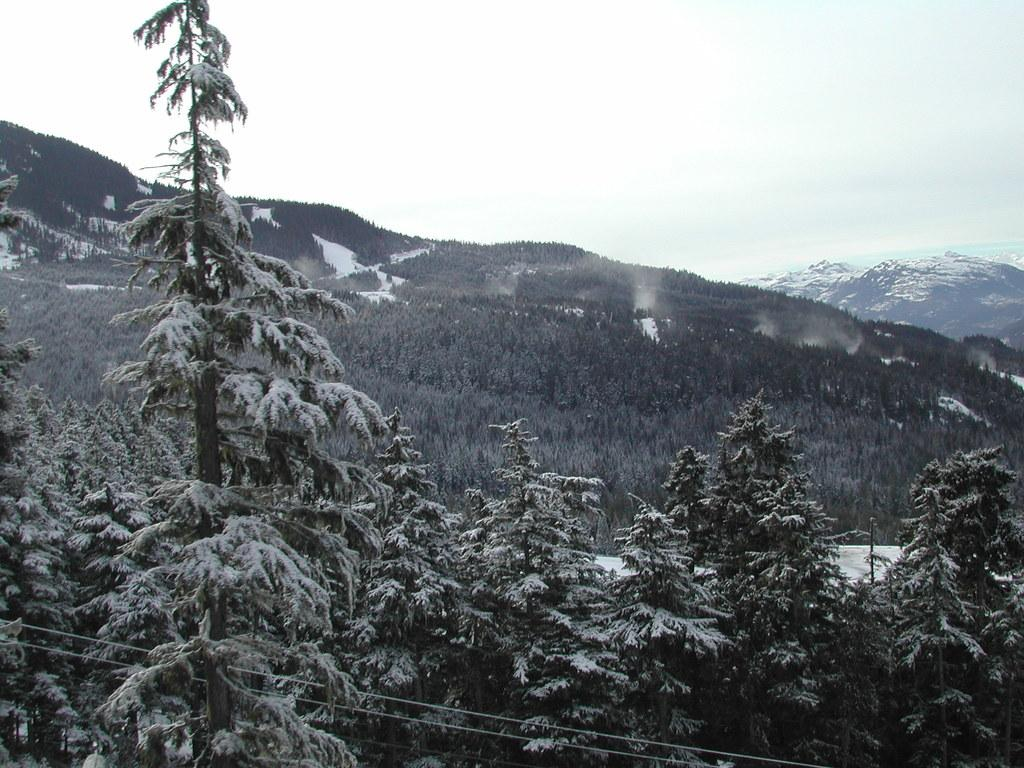What type of vegetation can be seen in the image? There are trees in the image. How are the trees in the image affected by the weather? The trees are covered with snow in the image. What geographical features are visible in the image? There are mountains in the image. How are the mountains in the image affected by the weather? The mountains are covered with snow in the image. What historical event is being commemorated by the waves in the image? There are no waves present in the image, so it is not possible to determine if any historical event is being commemorated. 